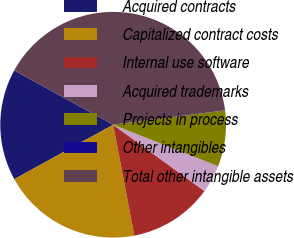Convert chart to OTSL. <chart><loc_0><loc_0><loc_500><loc_500><pie_chart><fcel>Acquired contracts<fcel>Capitalized contract costs<fcel>Internal use software<fcel>Acquired trademarks<fcel>Projects in process<fcel>Other intangibles<fcel>Total other intangible assets<nl><fcel>16.0%<fcel>19.99%<fcel>12.0%<fcel>4.01%<fcel>8.01%<fcel>0.02%<fcel>39.97%<nl></chart> 